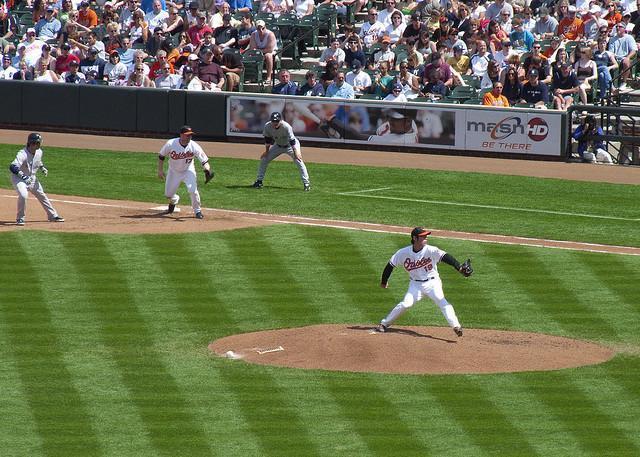How many people can you see?
Give a very brief answer. 5. How many cats are facing away?
Give a very brief answer. 0. 